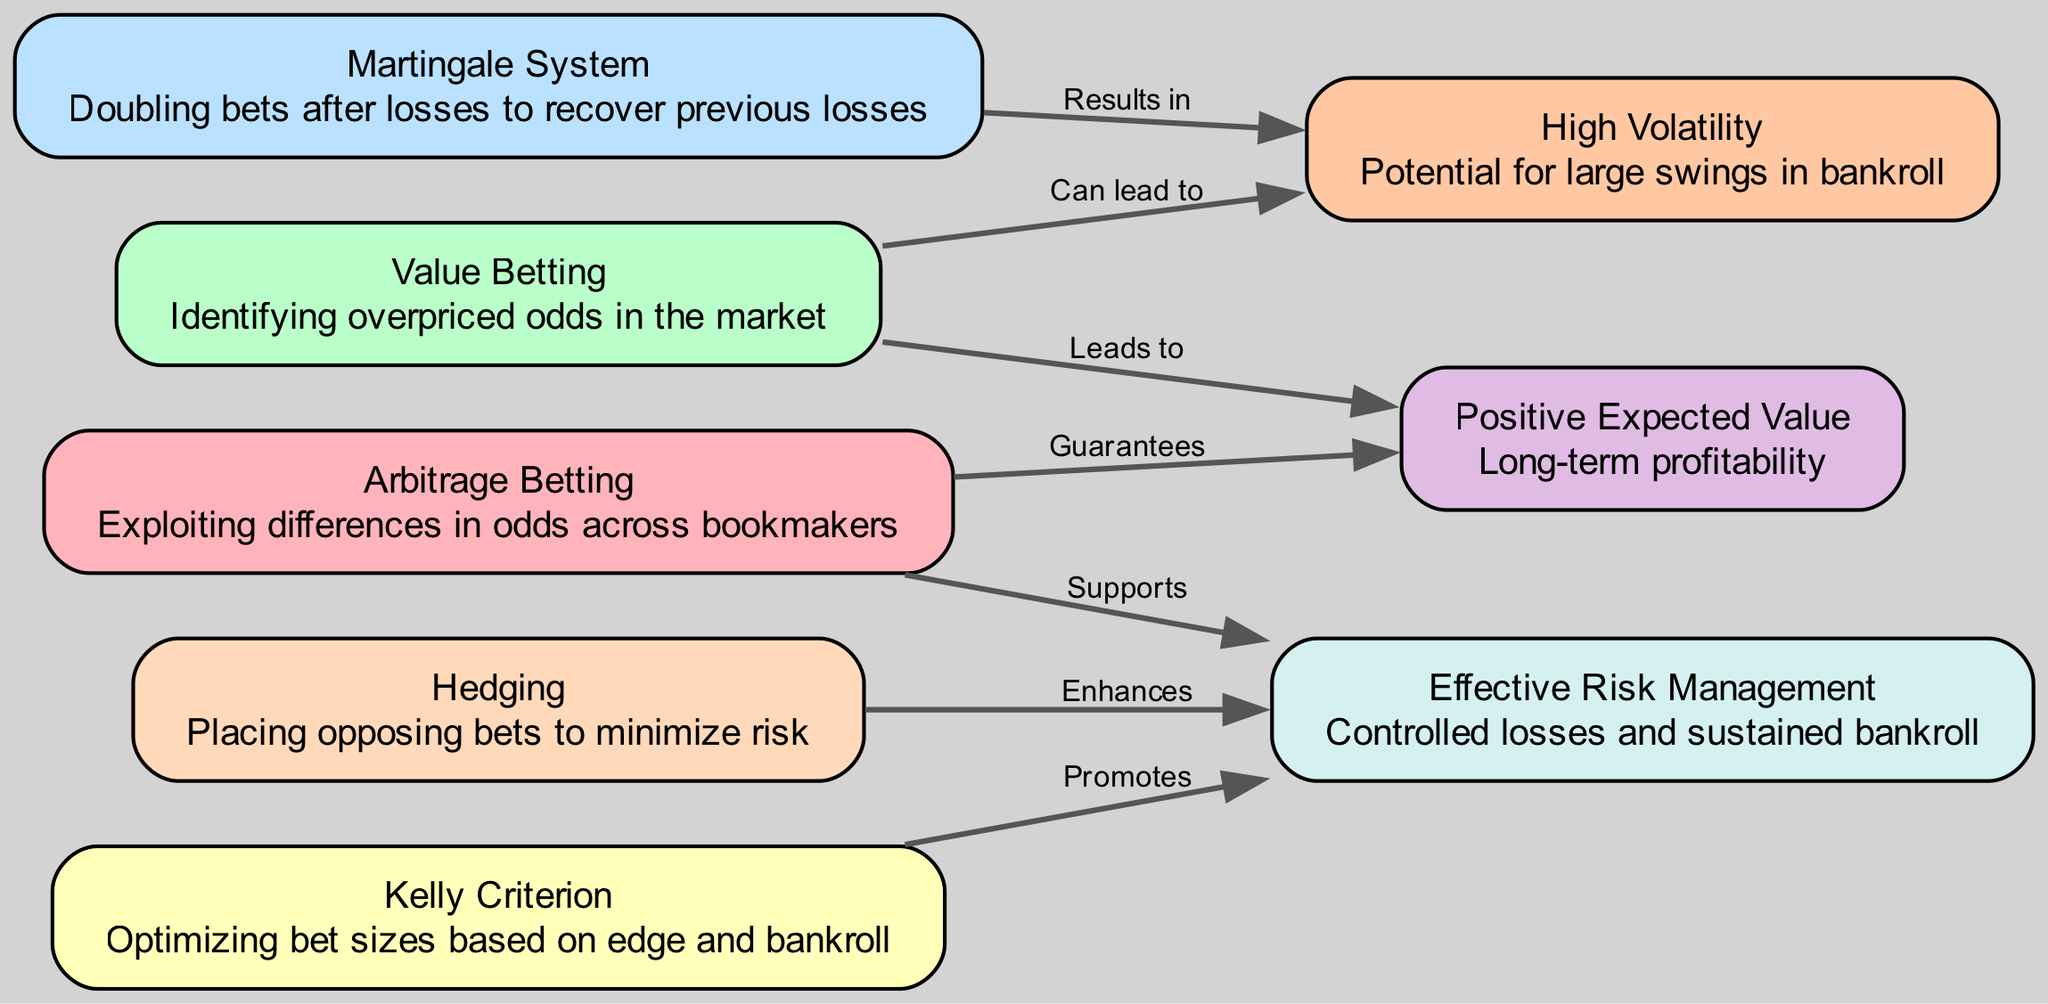What is the label of the node associated with hedging? The node that represents hedging is labeled "Hedging". This is directly mentioned in the node's description in the diagram.
Answer: Hedging How many nodes are present in the diagram? By counting the number of entries under the "nodes" section in the data, there are a total of 8 distinct betting strategies represented as nodes.
Answer: 8 Which strategy guarantees positive expected value? The diagram shows a direct edge labeled "Guarantees" that connects "Arbitrage Betting" to "Positive Expected Value", indicating that arbitrage betting is the strategy that guarantees this outcome.
Answer: Arbitrage Betting How does the Martingale system affect volatility? The connection in the diagram indicates that the "Martingale System" results in "High Volatility". This means that using this betting strategy is associated with significant fluctuations in a bettor's bankroll.
Answer: Results in Which strategies support effective risk management? The diagram shows that "Arbitrage Betting", "Kelly Criterion", and "Hedging" all link to "Effective Risk Management". Therefore, these three strategies enhance the management of risks in betting.
Answer: Arbitrage Betting, Kelly Criterion, Hedging What is the expected outcome of value betting? The diagram indicates that "Value Betting" leads to "Positive Expected Value", portraying the successful outcome of this strategy over time.
Answer: Positive Expected Value Which strategy is associated with controlled losses and sustained bankroll? "Risk Management" is the node that represents this concept, and its relationships with strategies like "Hedging" and "Kelly Criterion" emphasize its importance in sustainable betting practices.
Answer: Effective Risk Management What type of betting can lead to high volatility? The diagram clearly links "Value Betting" with "High Volatility" through the edge labeled "Can lead to", signifying that this approach can result in substantial variability.
Answer: Value Betting Which two strategies are directly connected to the concept of volatility? Both the "Martingale System" and "Value Betting" are related to the "High Volatility" outcome based on their respective connections in the diagram. This suggests both strategies can result in significant bankroll fluctuations.
Answer: Martingale System, Value Betting 